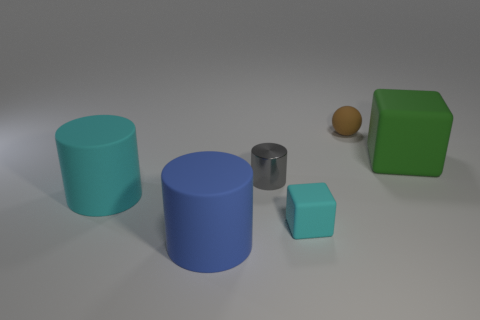There is a brown sphere that is the same material as the large cyan thing; what size is it?
Your response must be concise. Small. Is the number of blue rubber cubes less than the number of brown objects?
Make the answer very short. Yes. There is a cyan object behind the tiny rubber thing that is left of the tiny matte object that is behind the small rubber cube; what is it made of?
Make the answer very short. Rubber. Is the cylinder that is to the left of the large blue rubber thing made of the same material as the cyan thing right of the big blue thing?
Make the answer very short. Yes. How big is the object that is in front of the large cyan cylinder and to the left of the gray cylinder?
Your answer should be very brief. Large. What is the material of the cyan cube that is the same size as the sphere?
Your answer should be compact. Rubber. What number of big green matte things are in front of the tiny rubber object that is in front of the tiny rubber object behind the large green object?
Your answer should be very brief. 0. Do the block in front of the large cyan cylinder and the large matte cylinder that is behind the tiny cyan block have the same color?
Ensure brevity in your answer.  Yes. The large object that is behind the big blue object and left of the brown thing is what color?
Make the answer very short. Cyan. What number of blue rubber things have the same size as the brown thing?
Keep it short and to the point. 0. 